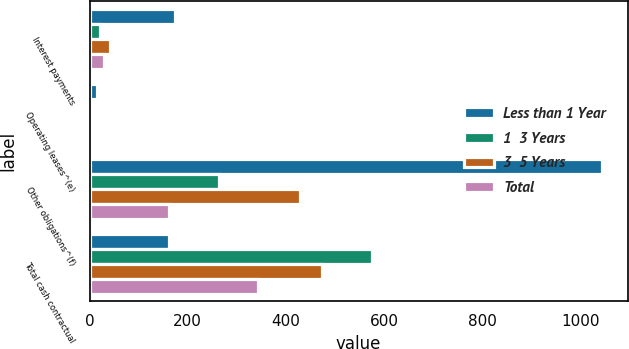Convert chart. <chart><loc_0><loc_0><loc_500><loc_500><stacked_bar_chart><ecel><fcel>Interest payments<fcel>Operating leases^(e)<fcel>Other obligations^(f)<fcel>Total cash contractual<nl><fcel>Less than 1 Year<fcel>173<fcel>16<fcel>1043<fcel>161<nl><fcel>1  3 Years<fcel>21<fcel>1<fcel>263<fcel>574<nl><fcel>3  5 Years<fcel>42<fcel>2<fcel>428<fcel>473<nl><fcel>Total<fcel>29<fcel>2<fcel>161<fcel>342<nl></chart> 